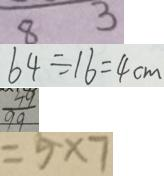<formula> <loc_0><loc_0><loc_500><loc_500>8 3 
 6 4 \div 1 6 = 4 c m 
 \frac { 4 9 } { 9 9 } 
 = 5 \times 7</formula> 